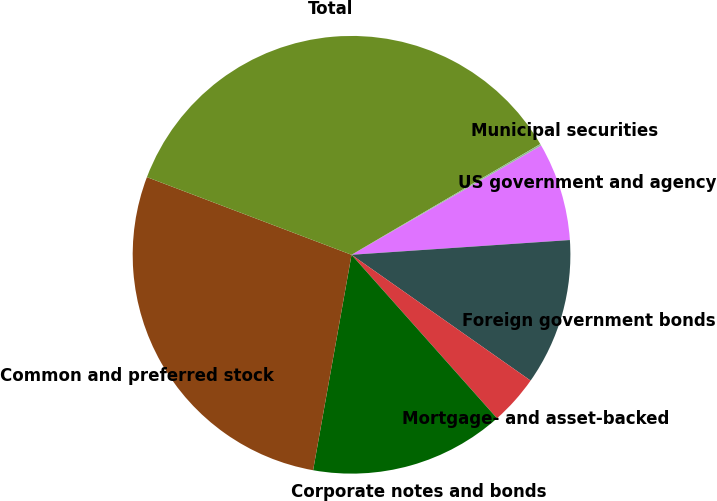Convert chart to OTSL. <chart><loc_0><loc_0><loc_500><loc_500><pie_chart><fcel>US government and agency<fcel>Foreign government bonds<fcel>Mortgage- and asset-backed<fcel>Corporate notes and bonds<fcel>Common and preferred stock<fcel>Total<fcel>Municipal securities<nl><fcel>7.25%<fcel>10.82%<fcel>3.68%<fcel>14.38%<fcel>27.96%<fcel>35.78%<fcel>0.12%<nl></chart> 